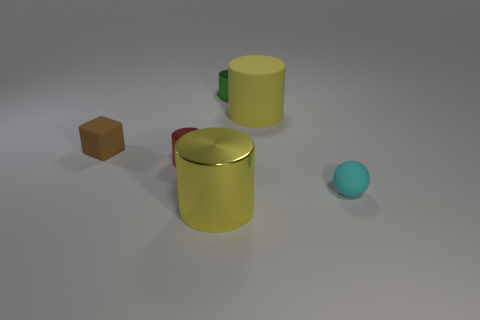Do the red object and the yellow object in front of the matte sphere have the same material?
Keep it short and to the point. Yes. There is a yellow rubber cylinder in front of the tiny green thing; are there any red objects behind it?
Keep it short and to the point. No. There is a matte thing that is both to the right of the small brown matte object and in front of the large rubber cylinder; what is its color?
Offer a very short reply. Cyan. The yellow shiny cylinder has what size?
Your response must be concise. Large. How many yellow things have the same size as the matte ball?
Offer a terse response. 0. Is the material of the small cylinder to the right of the large yellow shiny cylinder the same as the yellow cylinder in front of the tiny red metallic thing?
Give a very brief answer. Yes. What material is the yellow cylinder on the right side of the yellow thing that is to the left of the big yellow matte thing?
Keep it short and to the point. Rubber. There is a yellow cylinder that is in front of the tiny cyan thing; what is its material?
Your answer should be very brief. Metal. What number of red objects have the same shape as the cyan thing?
Your response must be concise. 0. Does the big shiny thing have the same color as the large matte object?
Offer a terse response. Yes. 